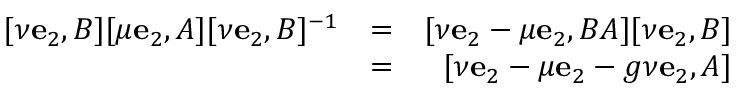Convert formula to latex. <formula><loc_0><loc_0><loc_500><loc_500>\begin{array} { r l r } { [ \nu e _ { 2 } , B ] [ \mu e _ { 2 } , A ] [ \nu e _ { 2 } , B ] ^ { - 1 } } & { = } & { [ \nu e _ { 2 } - \mu e _ { 2 } , B A ] [ \nu e _ { 2 } , B ] } \\ & { = } & { [ \nu e _ { 2 } - \mu e _ { 2 } - g \nu e _ { 2 } , A ] } \end{array}</formula> 